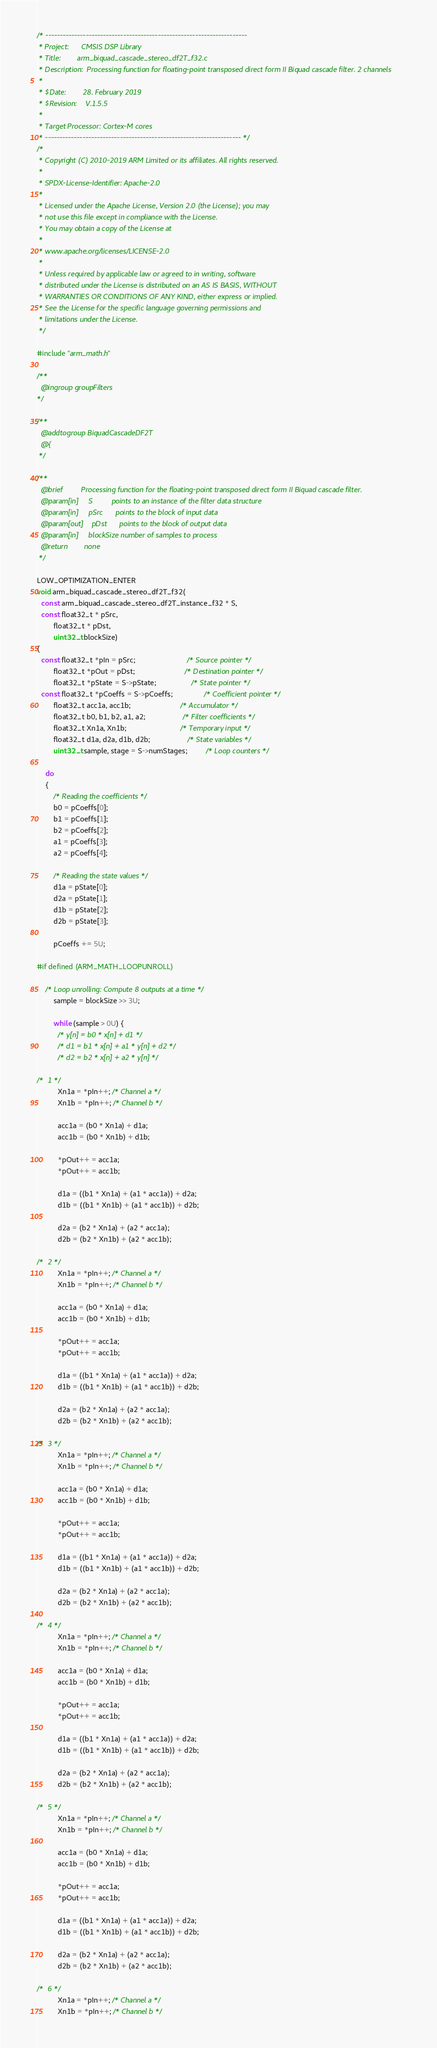<code> <loc_0><loc_0><loc_500><loc_500><_C_>/* ----------------------------------------------------------------------
 * Project:      CMSIS DSP Library
 * Title:        arm_biquad_cascade_stereo_df2T_f32.c
 * Description:  Processing function for floating-point transposed direct form II Biquad cascade filter. 2 channels
 *
 * $Date:        28. February 2019
 * $Revision:    V.1.5.5
 *
 * Target Processor: Cortex-M cores
 * -------------------------------------------------------------------- */
/*
 * Copyright (C) 2010-2019 ARM Limited or its affiliates. All rights reserved.
 *
 * SPDX-License-Identifier: Apache-2.0
 *
 * Licensed under the Apache License, Version 2.0 (the License); you may
 * not use this file except in compliance with the License.
 * You may obtain a copy of the License at
 *
 * www.apache.org/licenses/LICENSE-2.0
 *
 * Unless required by applicable law or agreed to in writing, software
 * distributed under the License is distributed on an AS IS BASIS, WITHOUT
 * WARRANTIES OR CONDITIONS OF ANY KIND, either express or implied.
 * See the License for the specific language governing permissions and
 * limitations under the License.
 */

#include "arm_math.h"

/**
  @ingroup groupFilters
*/

/**
  @addtogroup BiquadCascadeDF2T
  @{
 */

/**
  @brief         Processing function for the floating-point transposed direct form II Biquad cascade filter.
  @param[in]     S         points to an instance of the filter data structure
  @param[in]     pSrc      points to the block of input data
  @param[out]    pDst      points to the block of output data
  @param[in]     blockSize number of samples to process
  @return        none
 */

LOW_OPTIMIZATION_ENTER
void arm_biquad_cascade_stereo_df2T_f32(
  const arm_biquad_cascade_stereo_df2T_instance_f32 * S,
  const float32_t * pSrc,
        float32_t * pDst,
        uint32_t blockSize)
{
  const float32_t *pIn = pSrc;                         /* Source pointer */
        float32_t *pOut = pDst;                        /* Destination pointer */
        float32_t *pState = S->pState;                 /* State pointer */
  const float32_t *pCoeffs = S->pCoeffs;               /* Coefficient pointer */
        float32_t acc1a, acc1b;                        /* Accumulator */
        float32_t b0, b1, b2, a1, a2;                  /* Filter coefficients */
        float32_t Xn1a, Xn1b;                          /* Temporary input */
        float32_t d1a, d2a, d1b, d2b;                  /* State variables */
        uint32_t sample, stage = S->numStages;         /* Loop counters */

    do
    {
        /* Reading the coefficients */
        b0 = pCoeffs[0];
        b1 = pCoeffs[1];
        b2 = pCoeffs[2];
        a1 = pCoeffs[3];
        a2 = pCoeffs[4];

        /* Reading the state values */
        d1a = pState[0];
        d2a = pState[1];
        d1b = pState[2];
        d2b = pState[3];

        pCoeffs += 5U;

#if defined (ARM_MATH_LOOPUNROLL)

    /* Loop unrolling: Compute 8 outputs at a time */
        sample = blockSize >> 3U;

        while (sample > 0U) {
          /* y[n] = b0 * x[n] + d1 */
          /* d1 = b1 * x[n] + a1 * y[n] + d2 */
          /* d2 = b2 * x[n] + a2 * y[n] */

/*  1 */
          Xn1a = *pIn++; /* Channel a */
          Xn1b = *pIn++; /* Channel b */

          acc1a = (b0 * Xn1a) + d1a;
          acc1b = (b0 * Xn1b) + d1b;

          *pOut++ = acc1a;
          *pOut++ = acc1b;

          d1a = ((b1 * Xn1a) + (a1 * acc1a)) + d2a;
          d1b = ((b1 * Xn1b) + (a1 * acc1b)) + d2b;

          d2a = (b2 * Xn1a) + (a2 * acc1a);
          d2b = (b2 * Xn1b) + (a2 * acc1b);

/*  2 */
          Xn1a = *pIn++; /* Channel a */
          Xn1b = *pIn++; /* Channel b */

          acc1a = (b0 * Xn1a) + d1a;
          acc1b = (b0 * Xn1b) + d1b;

          *pOut++ = acc1a;
          *pOut++ = acc1b;

          d1a = ((b1 * Xn1a) + (a1 * acc1a)) + d2a;
          d1b = ((b1 * Xn1b) + (a1 * acc1b)) + d2b;

          d2a = (b2 * Xn1a) + (a2 * acc1a);
          d2b = (b2 * Xn1b) + (a2 * acc1b);

/*  3 */
          Xn1a = *pIn++; /* Channel a */
          Xn1b = *pIn++; /* Channel b */

          acc1a = (b0 * Xn1a) + d1a;
          acc1b = (b0 * Xn1b) + d1b;

          *pOut++ = acc1a;
          *pOut++ = acc1b;

          d1a = ((b1 * Xn1a) + (a1 * acc1a)) + d2a;
          d1b = ((b1 * Xn1b) + (a1 * acc1b)) + d2b;

          d2a = (b2 * Xn1a) + (a2 * acc1a);
          d2b = (b2 * Xn1b) + (a2 * acc1b);

/*  4 */
          Xn1a = *pIn++; /* Channel a */
          Xn1b = *pIn++; /* Channel b */

          acc1a = (b0 * Xn1a) + d1a;
          acc1b = (b0 * Xn1b) + d1b;

          *pOut++ = acc1a;
          *pOut++ = acc1b;

          d1a = ((b1 * Xn1a) + (a1 * acc1a)) + d2a;
          d1b = ((b1 * Xn1b) + (a1 * acc1b)) + d2b;

          d2a = (b2 * Xn1a) + (a2 * acc1a);
          d2b = (b2 * Xn1b) + (a2 * acc1b);

/*  5 */
          Xn1a = *pIn++; /* Channel a */
          Xn1b = *pIn++; /* Channel b */

          acc1a = (b0 * Xn1a) + d1a;
          acc1b = (b0 * Xn1b) + d1b;

          *pOut++ = acc1a;
          *pOut++ = acc1b;

          d1a = ((b1 * Xn1a) + (a1 * acc1a)) + d2a;
          d1b = ((b1 * Xn1b) + (a1 * acc1b)) + d2b;

          d2a = (b2 * Xn1a) + (a2 * acc1a);
          d2b = (b2 * Xn1b) + (a2 * acc1b);

/*  6 */
          Xn1a = *pIn++; /* Channel a */
          Xn1b = *pIn++; /* Channel b */
</code> 